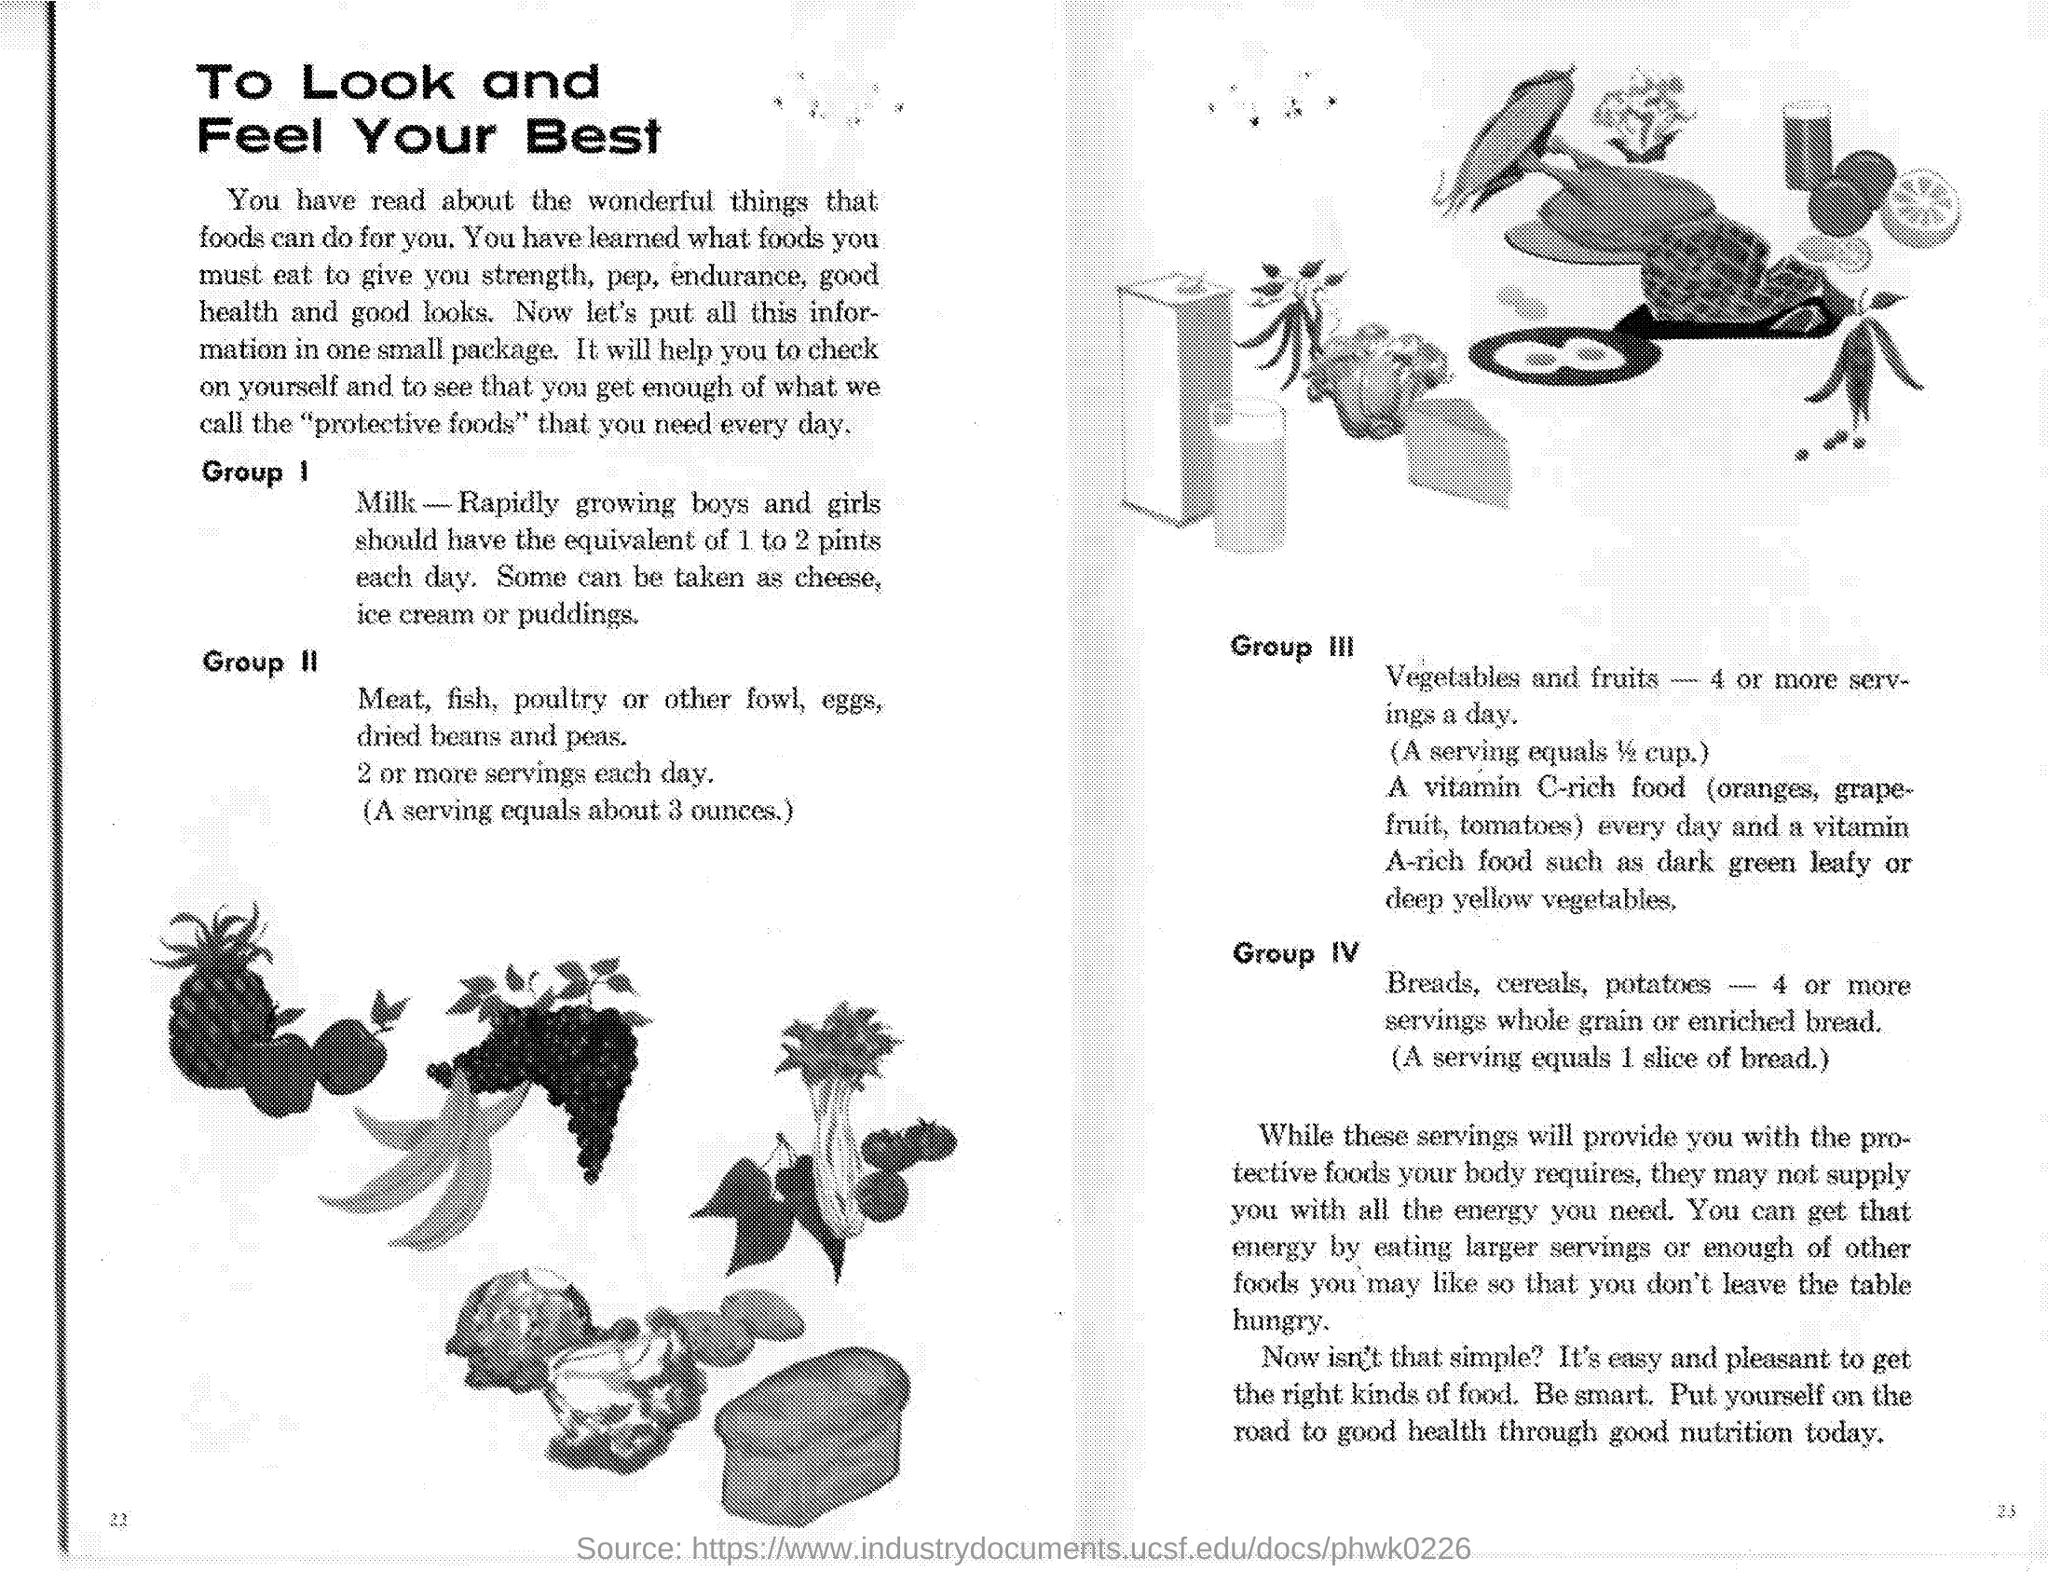Identify some key points in this picture. It is recommended that individuals consume at least 4 servings of vegetables and fruits per day. Rapidly growing boys and girls should consume 1 to 2 pints of milk per day. Group I contains milk as one of its food items. It is approximately 3 ounces per serving. 